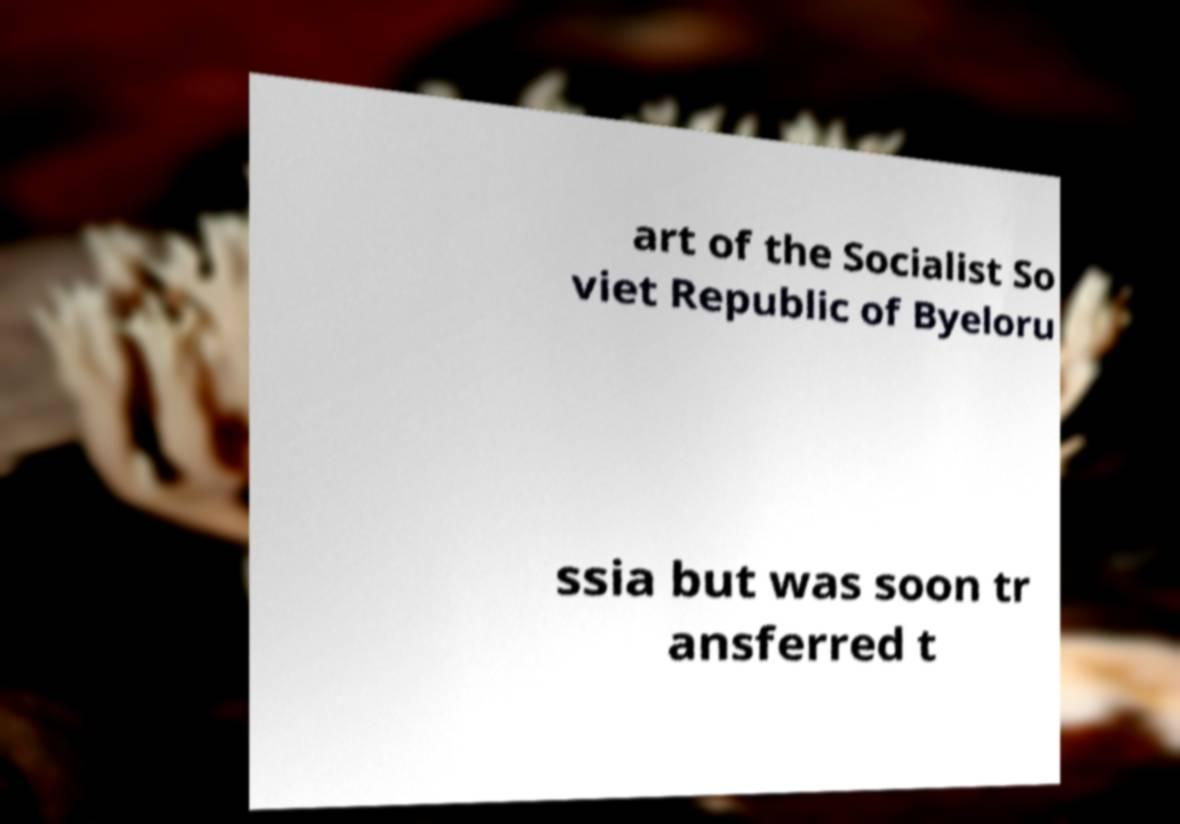Please read and relay the text visible in this image. What does it say? art of the Socialist So viet Republic of Byeloru ssia but was soon tr ansferred t 